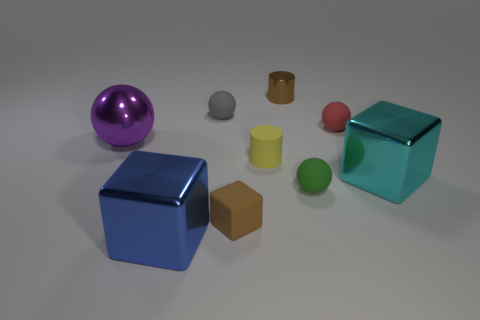Subtract all purple metal spheres. How many spheres are left? 3 Subtract all yellow spheres. Subtract all blue blocks. How many spheres are left? 4 Subtract all blocks. How many objects are left? 6 Subtract 0 gray blocks. How many objects are left? 9 Subtract all red balls. Subtract all green spheres. How many objects are left? 7 Add 8 big cyan shiny things. How many big cyan shiny things are left? 9 Add 5 tiny blue metal objects. How many tiny blue metal objects exist? 5 